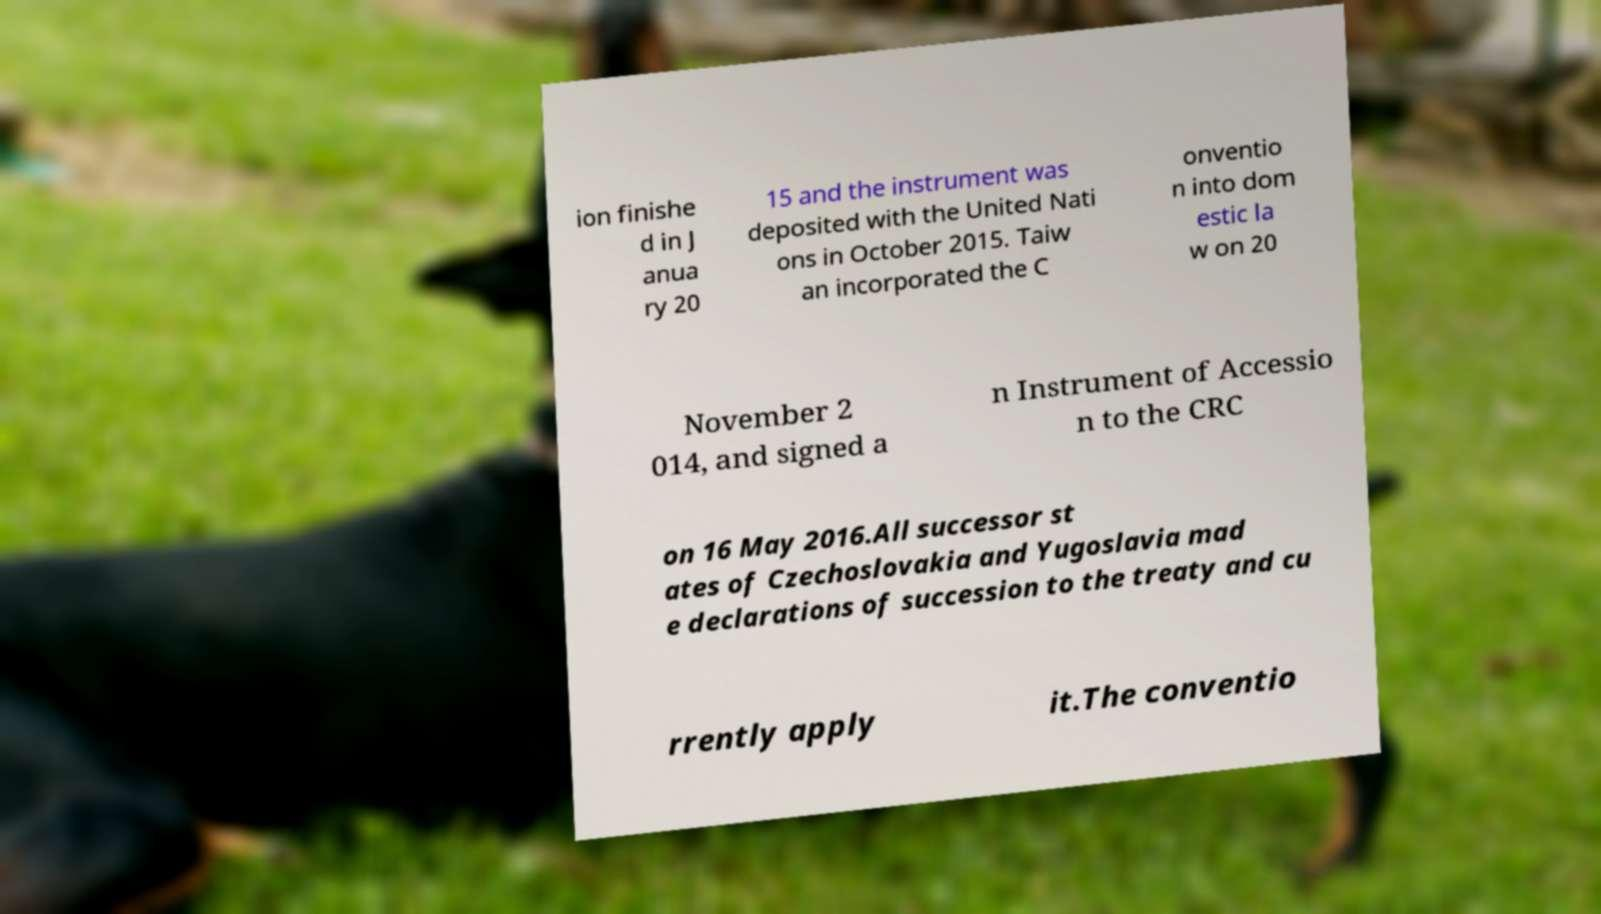For documentation purposes, I need the text within this image transcribed. Could you provide that? ion finishe d in J anua ry 20 15 and the instrument was deposited with the United Nati ons in October 2015. Taiw an incorporated the C onventio n into dom estic la w on 20 November 2 014, and signed a n Instrument of Accessio n to the CRC on 16 May 2016.All successor st ates of Czechoslovakia and Yugoslavia mad e declarations of succession to the treaty and cu rrently apply it.The conventio 